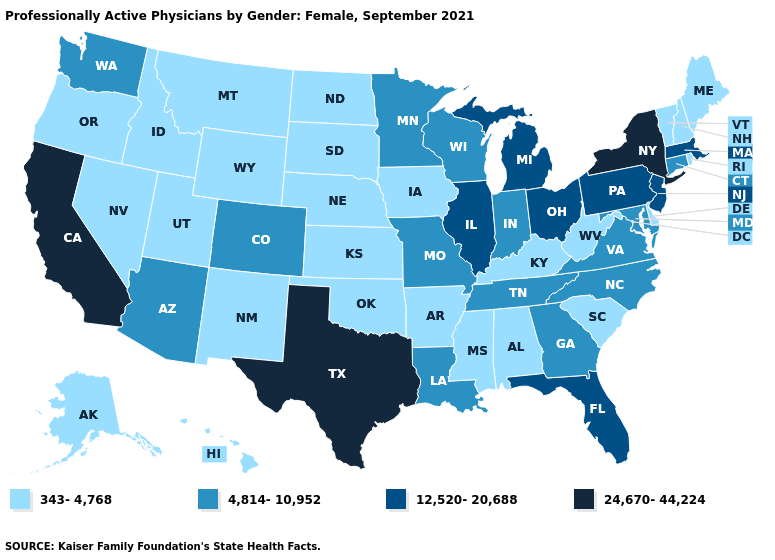Which states hav the highest value in the Northeast?
Answer briefly. New York. Name the states that have a value in the range 12,520-20,688?
Write a very short answer. Florida, Illinois, Massachusetts, Michigan, New Jersey, Ohio, Pennsylvania. Is the legend a continuous bar?
Be succinct. No. Does the map have missing data?
Answer briefly. No. Which states hav the highest value in the South?
Short answer required. Texas. Name the states that have a value in the range 343-4,768?
Short answer required. Alabama, Alaska, Arkansas, Delaware, Hawaii, Idaho, Iowa, Kansas, Kentucky, Maine, Mississippi, Montana, Nebraska, Nevada, New Hampshire, New Mexico, North Dakota, Oklahoma, Oregon, Rhode Island, South Carolina, South Dakota, Utah, Vermont, West Virginia, Wyoming. Among the states that border North Dakota , which have the highest value?
Concise answer only. Minnesota. Among the states that border Michigan , which have the lowest value?
Concise answer only. Indiana, Wisconsin. How many symbols are there in the legend?
Keep it brief. 4. What is the highest value in the South ?
Be succinct. 24,670-44,224. Does New Jersey have the same value as Ohio?
Be succinct. Yes. What is the value of Kentucky?
Keep it brief. 343-4,768. How many symbols are there in the legend?
Be succinct. 4. What is the highest value in the USA?
Concise answer only. 24,670-44,224. 